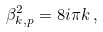<formula> <loc_0><loc_0><loc_500><loc_500>\beta _ { k , p } ^ { 2 } = 8 i \pi k \, ,</formula> 